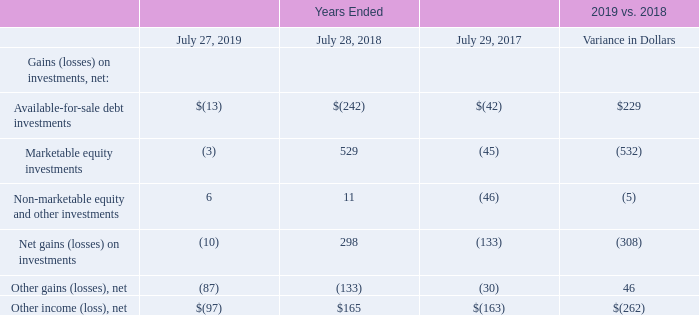Other Income (Loss), Net The components of other income (loss), net, are summarized as follows (in millions):
The total change in net gains (losses) on available-for-sale debt investments was primarily attributable to lower realized losses as a result of market conditions, and the timing of sales of these investments.
The total change in net gains (losses) on marketable equity investments was attributable to market value fluctuations and the timing of recognition of gains and losses.
The change in net gains (losses) on non-marketable equity and other investments was primarily due to lower realized gains, partially offset by higher unrealized gains.
The change in other gains (losses), net was primarily driven by higher donation expense in the prior year.
What was the  total change in net gains (losses) on marketable equity investments attributable to? Market value fluctuations and the timing of recognition of gains and losses. What was the change in net gains (losses) on non-marketable equity and other investments primarily due to? Lower realized gains, partially offset by higher unrealized gains. Which years does the table provide information for the components of net other income (loss)? 2019, 2018, 2017. What was the change in Non-marketable equity and other investments between 2017 and 2018?
Answer scale should be: million. 11-(-46)
Answer: 57. What was the difference in the variance in dollars between Available-for-sale debt investments and net Other gains (losses)?
Answer scale should be: million. 229-46
Answer: 183. What was the percentage change in the net other gains (losses) between 2017 and 2018?
Answer scale should be: percent. (-133-(-30))/-30
Answer: 343.33. 